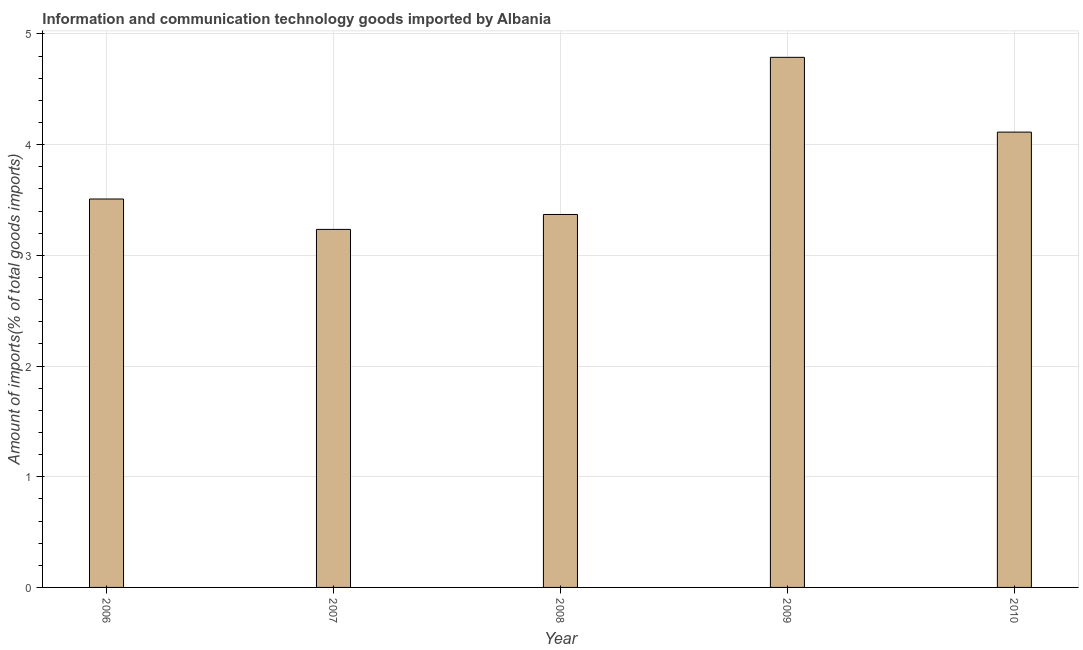Does the graph contain grids?
Your answer should be compact. Yes. What is the title of the graph?
Offer a terse response. Information and communication technology goods imported by Albania. What is the label or title of the X-axis?
Your answer should be very brief. Year. What is the label or title of the Y-axis?
Make the answer very short. Amount of imports(% of total goods imports). What is the amount of ict goods imports in 2009?
Keep it short and to the point. 4.79. Across all years, what is the maximum amount of ict goods imports?
Give a very brief answer. 4.79. Across all years, what is the minimum amount of ict goods imports?
Your answer should be compact. 3.23. In which year was the amount of ict goods imports maximum?
Your response must be concise. 2009. What is the sum of the amount of ict goods imports?
Provide a short and direct response. 19.01. What is the difference between the amount of ict goods imports in 2008 and 2009?
Give a very brief answer. -1.42. What is the average amount of ict goods imports per year?
Provide a succinct answer. 3.8. What is the median amount of ict goods imports?
Offer a terse response. 3.51. In how many years, is the amount of ict goods imports greater than 3.8 %?
Provide a succinct answer. 2. What is the ratio of the amount of ict goods imports in 2006 to that in 2010?
Keep it short and to the point. 0.85. Is the amount of ict goods imports in 2009 less than that in 2010?
Offer a terse response. No. What is the difference between the highest and the second highest amount of ict goods imports?
Your answer should be very brief. 0.68. What is the difference between the highest and the lowest amount of ict goods imports?
Your answer should be very brief. 1.55. In how many years, is the amount of ict goods imports greater than the average amount of ict goods imports taken over all years?
Provide a short and direct response. 2. How many years are there in the graph?
Your answer should be compact. 5. Are the values on the major ticks of Y-axis written in scientific E-notation?
Your answer should be very brief. No. What is the Amount of imports(% of total goods imports) in 2006?
Your answer should be very brief. 3.51. What is the Amount of imports(% of total goods imports) in 2007?
Ensure brevity in your answer.  3.23. What is the Amount of imports(% of total goods imports) in 2008?
Give a very brief answer. 3.37. What is the Amount of imports(% of total goods imports) in 2009?
Keep it short and to the point. 4.79. What is the Amount of imports(% of total goods imports) of 2010?
Your response must be concise. 4.11. What is the difference between the Amount of imports(% of total goods imports) in 2006 and 2007?
Your response must be concise. 0.27. What is the difference between the Amount of imports(% of total goods imports) in 2006 and 2008?
Keep it short and to the point. 0.14. What is the difference between the Amount of imports(% of total goods imports) in 2006 and 2009?
Give a very brief answer. -1.28. What is the difference between the Amount of imports(% of total goods imports) in 2006 and 2010?
Your response must be concise. -0.6. What is the difference between the Amount of imports(% of total goods imports) in 2007 and 2008?
Give a very brief answer. -0.13. What is the difference between the Amount of imports(% of total goods imports) in 2007 and 2009?
Offer a very short reply. -1.55. What is the difference between the Amount of imports(% of total goods imports) in 2007 and 2010?
Provide a succinct answer. -0.88. What is the difference between the Amount of imports(% of total goods imports) in 2008 and 2009?
Provide a short and direct response. -1.42. What is the difference between the Amount of imports(% of total goods imports) in 2008 and 2010?
Provide a succinct answer. -0.74. What is the difference between the Amount of imports(% of total goods imports) in 2009 and 2010?
Give a very brief answer. 0.68. What is the ratio of the Amount of imports(% of total goods imports) in 2006 to that in 2007?
Keep it short and to the point. 1.08. What is the ratio of the Amount of imports(% of total goods imports) in 2006 to that in 2008?
Your response must be concise. 1.04. What is the ratio of the Amount of imports(% of total goods imports) in 2006 to that in 2009?
Your answer should be very brief. 0.73. What is the ratio of the Amount of imports(% of total goods imports) in 2006 to that in 2010?
Provide a short and direct response. 0.85. What is the ratio of the Amount of imports(% of total goods imports) in 2007 to that in 2008?
Offer a very short reply. 0.96. What is the ratio of the Amount of imports(% of total goods imports) in 2007 to that in 2009?
Give a very brief answer. 0.68. What is the ratio of the Amount of imports(% of total goods imports) in 2007 to that in 2010?
Keep it short and to the point. 0.79. What is the ratio of the Amount of imports(% of total goods imports) in 2008 to that in 2009?
Offer a terse response. 0.7. What is the ratio of the Amount of imports(% of total goods imports) in 2008 to that in 2010?
Make the answer very short. 0.82. What is the ratio of the Amount of imports(% of total goods imports) in 2009 to that in 2010?
Offer a very short reply. 1.16. 